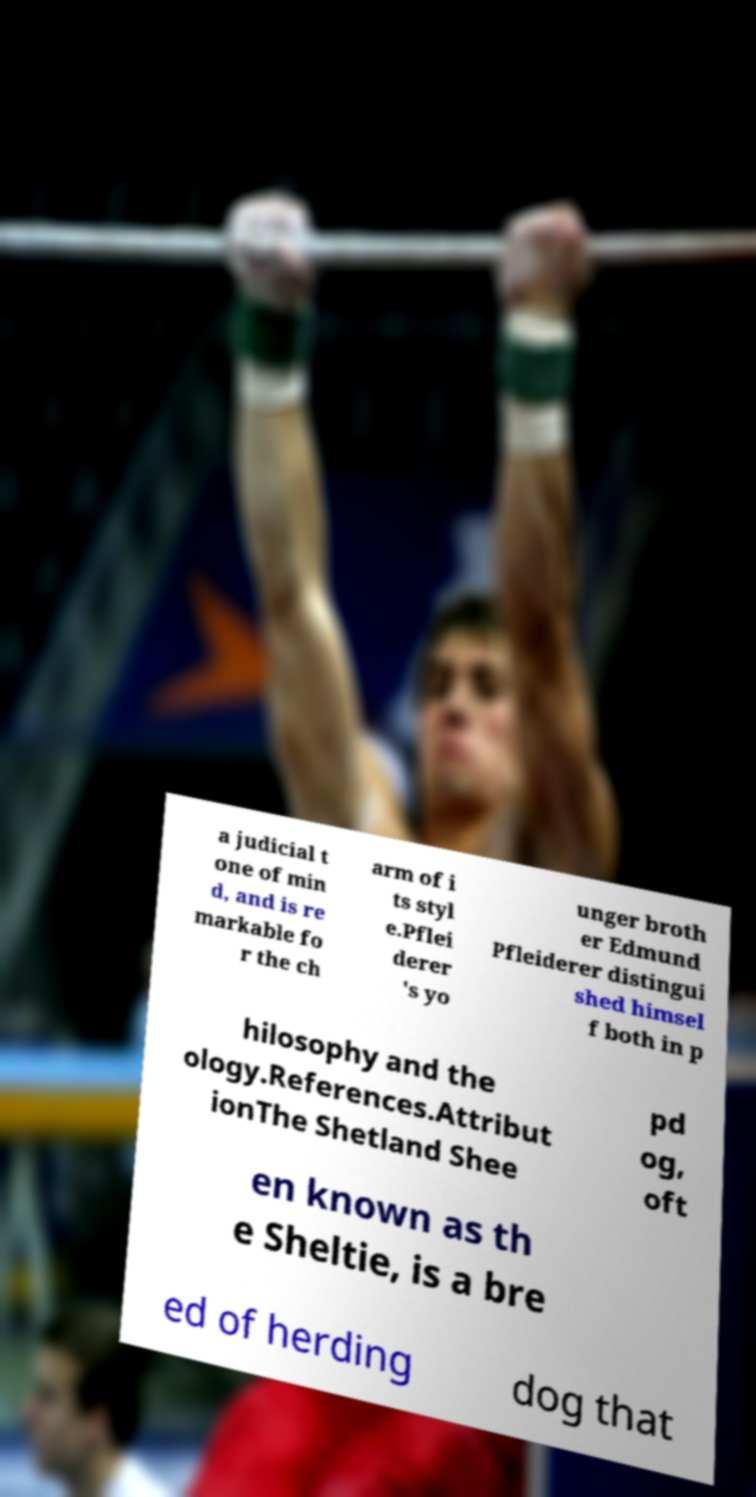Could you extract and type out the text from this image? a judicial t one of min d, and is re markable fo r the ch arm of i ts styl e.Pflei derer 's yo unger broth er Edmund Pfleiderer distingui shed himsel f both in p hilosophy and the ology.References.Attribut ionThe Shetland Shee pd og, oft en known as th e Sheltie, is a bre ed of herding dog that 